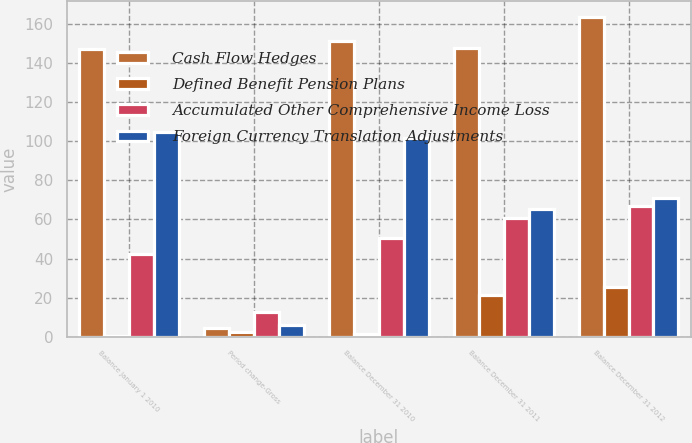Convert chart. <chart><loc_0><loc_0><loc_500><loc_500><stacked_bar_chart><ecel><fcel>Balance January 1 2010<fcel>Period change-Gross<fcel>Balance December 31 2010<fcel>Balance December 31 2011<fcel>Balance December 31 2012<nl><fcel>Cash Flow Hedges<fcel>147.2<fcel>4.5<fcel>151.1<fcel>147.6<fcel>163.5<nl><fcel>Defined Benefit Pension Plans<fcel>0.1<fcel>2.2<fcel>1.4<fcel>21.5<fcel>25.5<nl><fcel>Accumulated Other Comprehensive Income Loss<fcel>42.5<fcel>12.7<fcel>50.7<fcel>60.9<fcel>67<nl><fcel>Foreign Currency Translation Adjustments<fcel>104.8<fcel>6<fcel>101.8<fcel>65.2<fcel>71<nl></chart> 